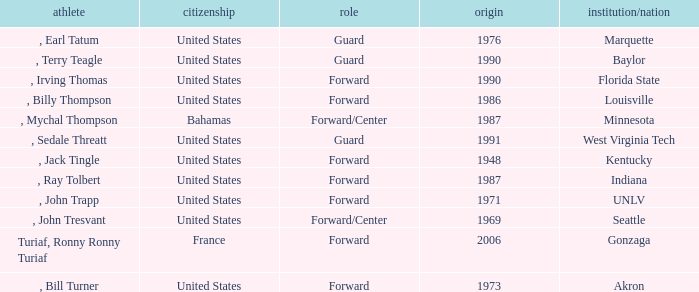What was the nationality of every player that attended Baylor? United States. 